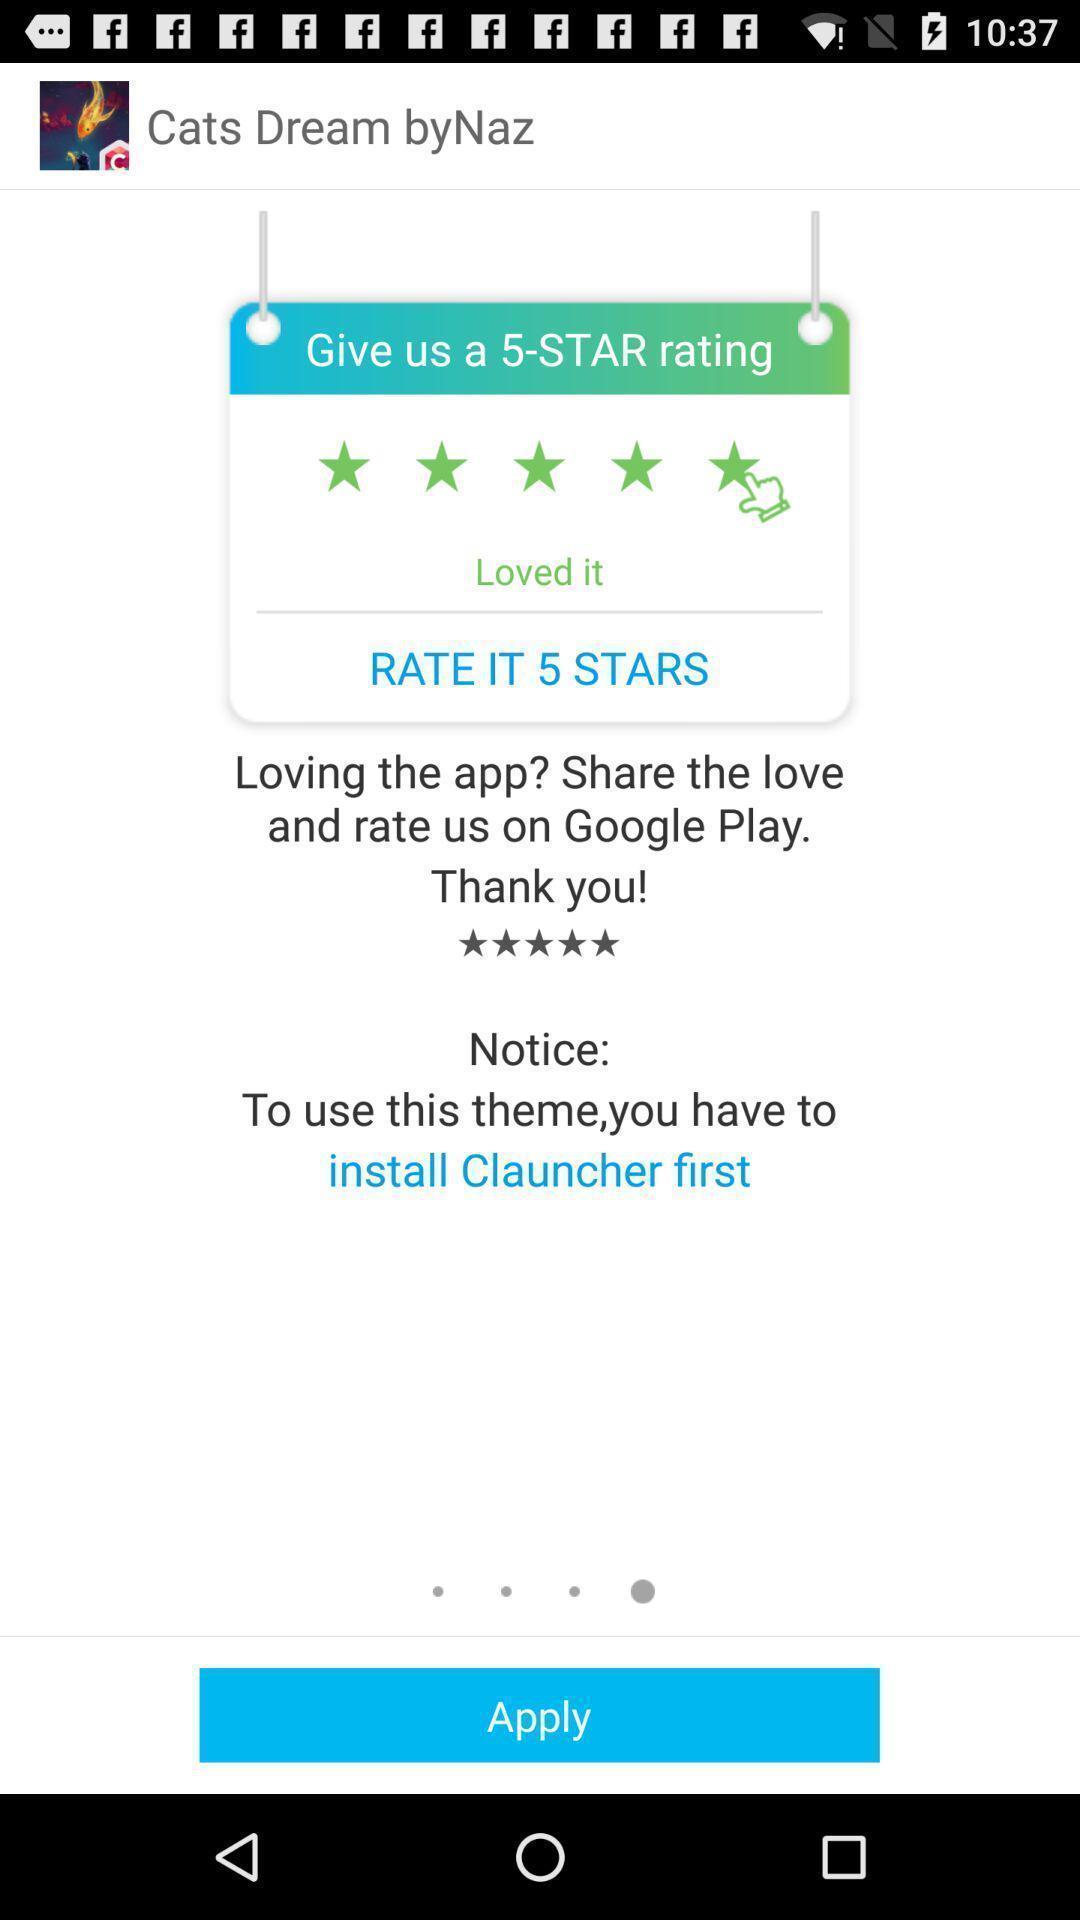Describe the visual elements of this screenshot. Screen shows about a rating. 